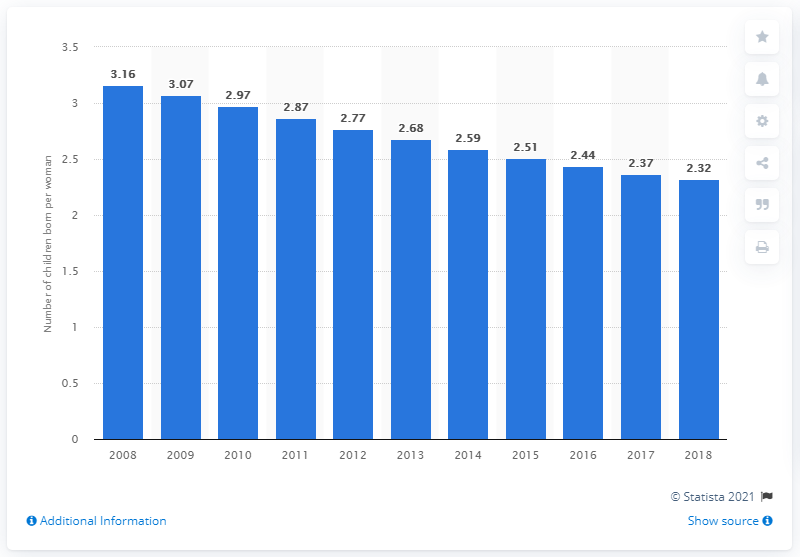Outline some significant characteristics in this image. In 2018, the fertility rate in Saudi Arabia was 2.32 children per woman. 